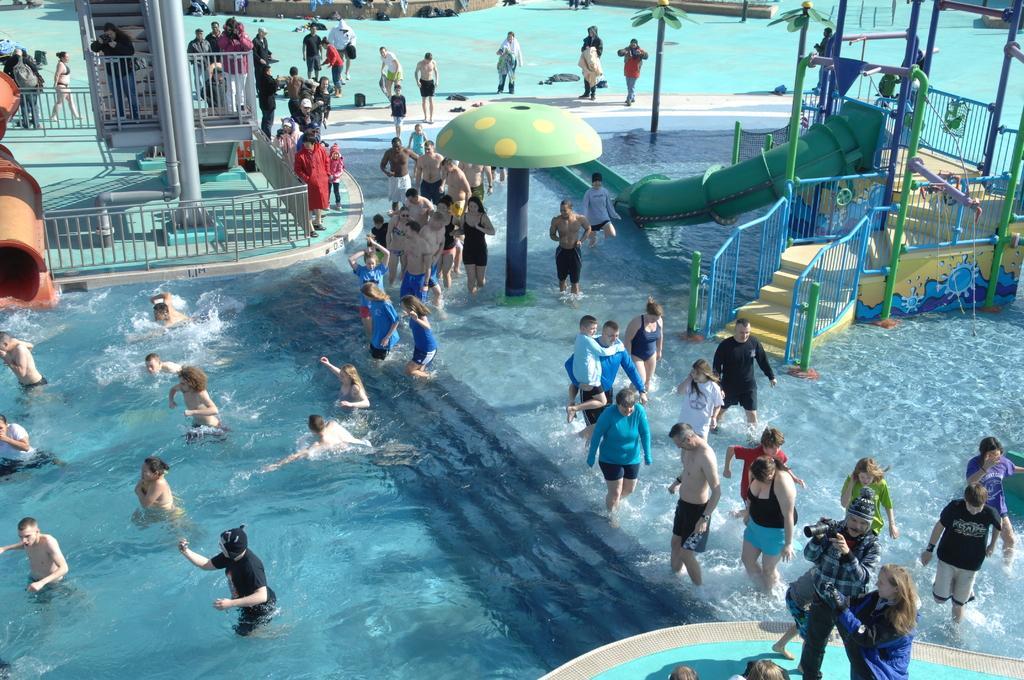How would you summarize this image in a sentence or two? In this image there are few persons are in water. There are few staircase having a pipe attached to it. Left side there is a fence behind there is a pole. A person is standing behind the fence and holding camera. Behind her there is staircase. Few persons are on the floor. 